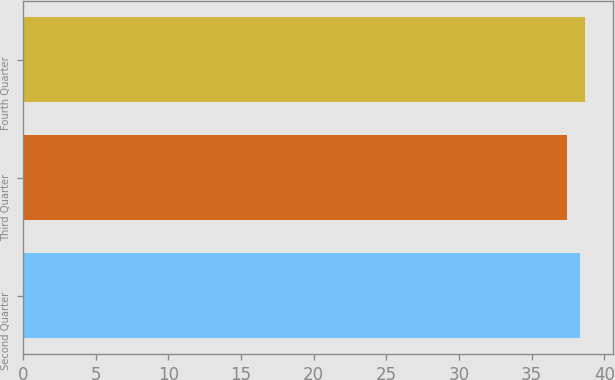Convert chart. <chart><loc_0><loc_0><loc_500><loc_500><bar_chart><fcel>Second Quarter<fcel>Third Quarter<fcel>Fourth Quarter<nl><fcel>38.34<fcel>37.41<fcel>38.64<nl></chart> 